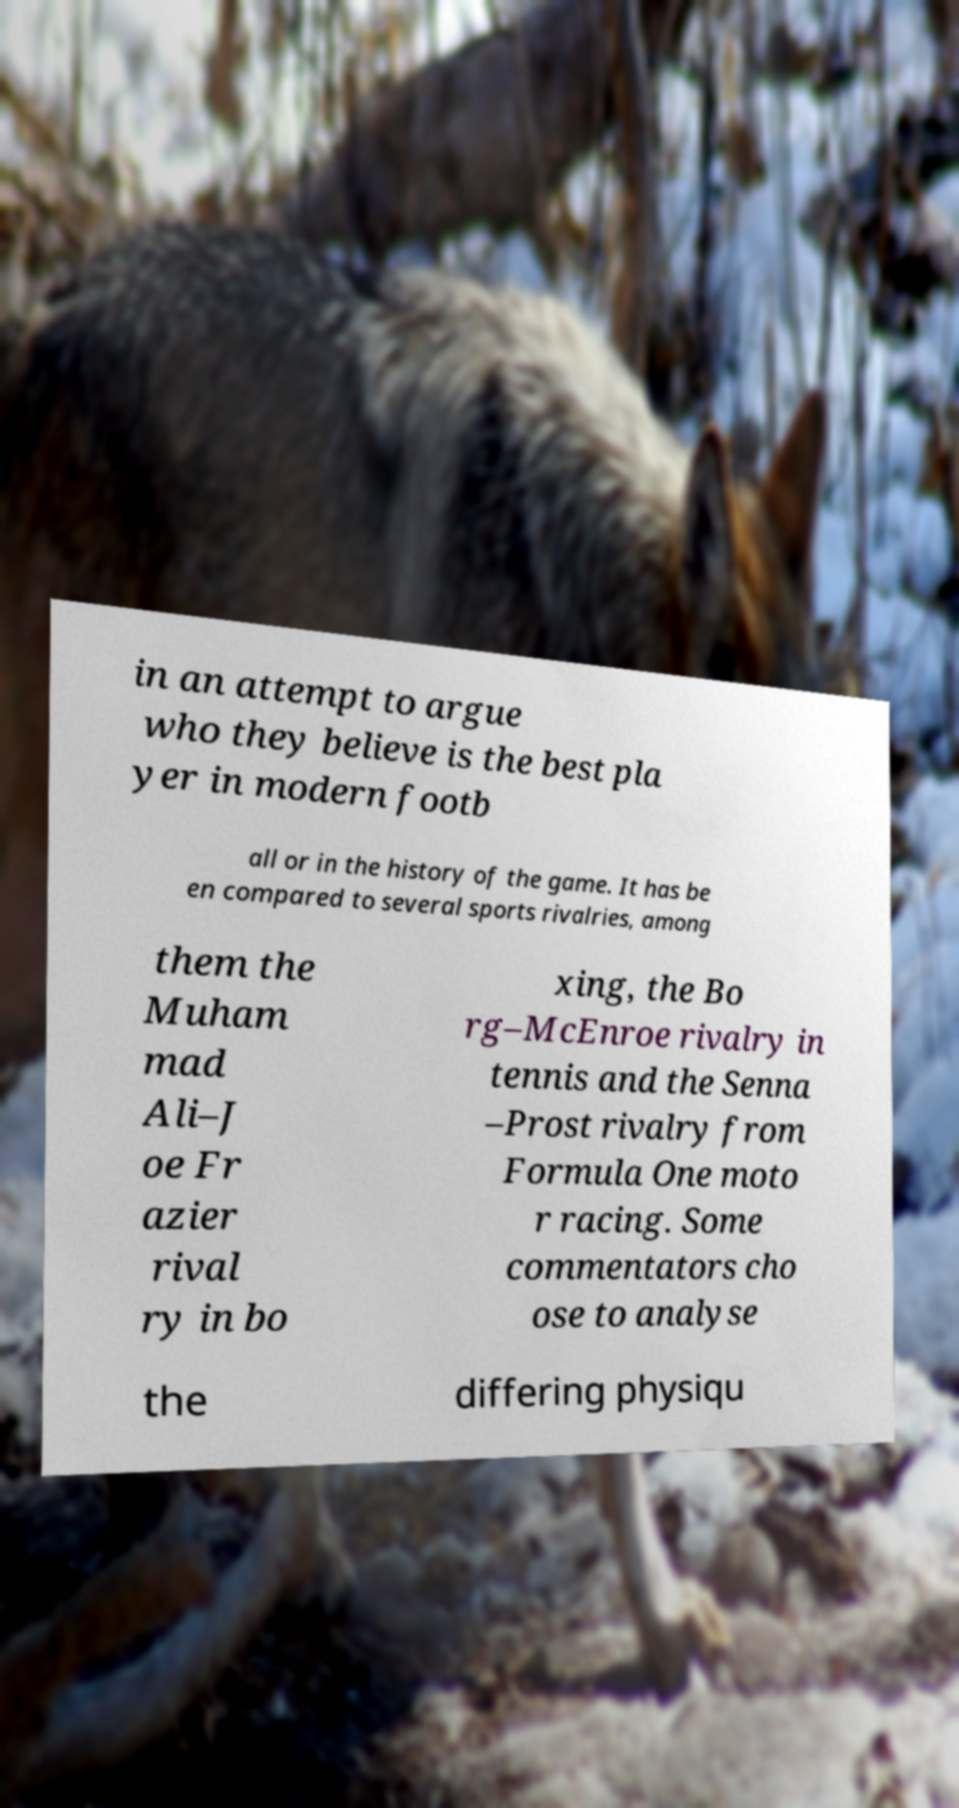Can you accurately transcribe the text from the provided image for me? in an attempt to argue who they believe is the best pla yer in modern footb all or in the history of the game. It has be en compared to several sports rivalries, among them the Muham mad Ali–J oe Fr azier rival ry in bo xing, the Bo rg–McEnroe rivalry in tennis and the Senna –Prost rivalry from Formula One moto r racing. Some commentators cho ose to analyse the differing physiqu 